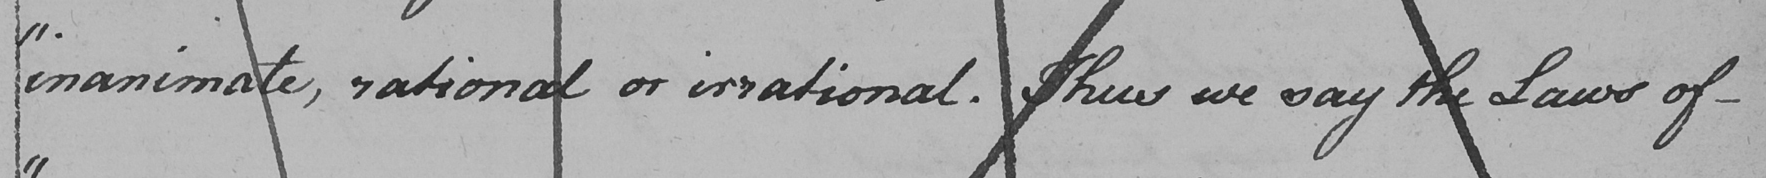Can you read and transcribe this handwriting? " inanimate , rational or irrational . Thus we say the Laws of- 